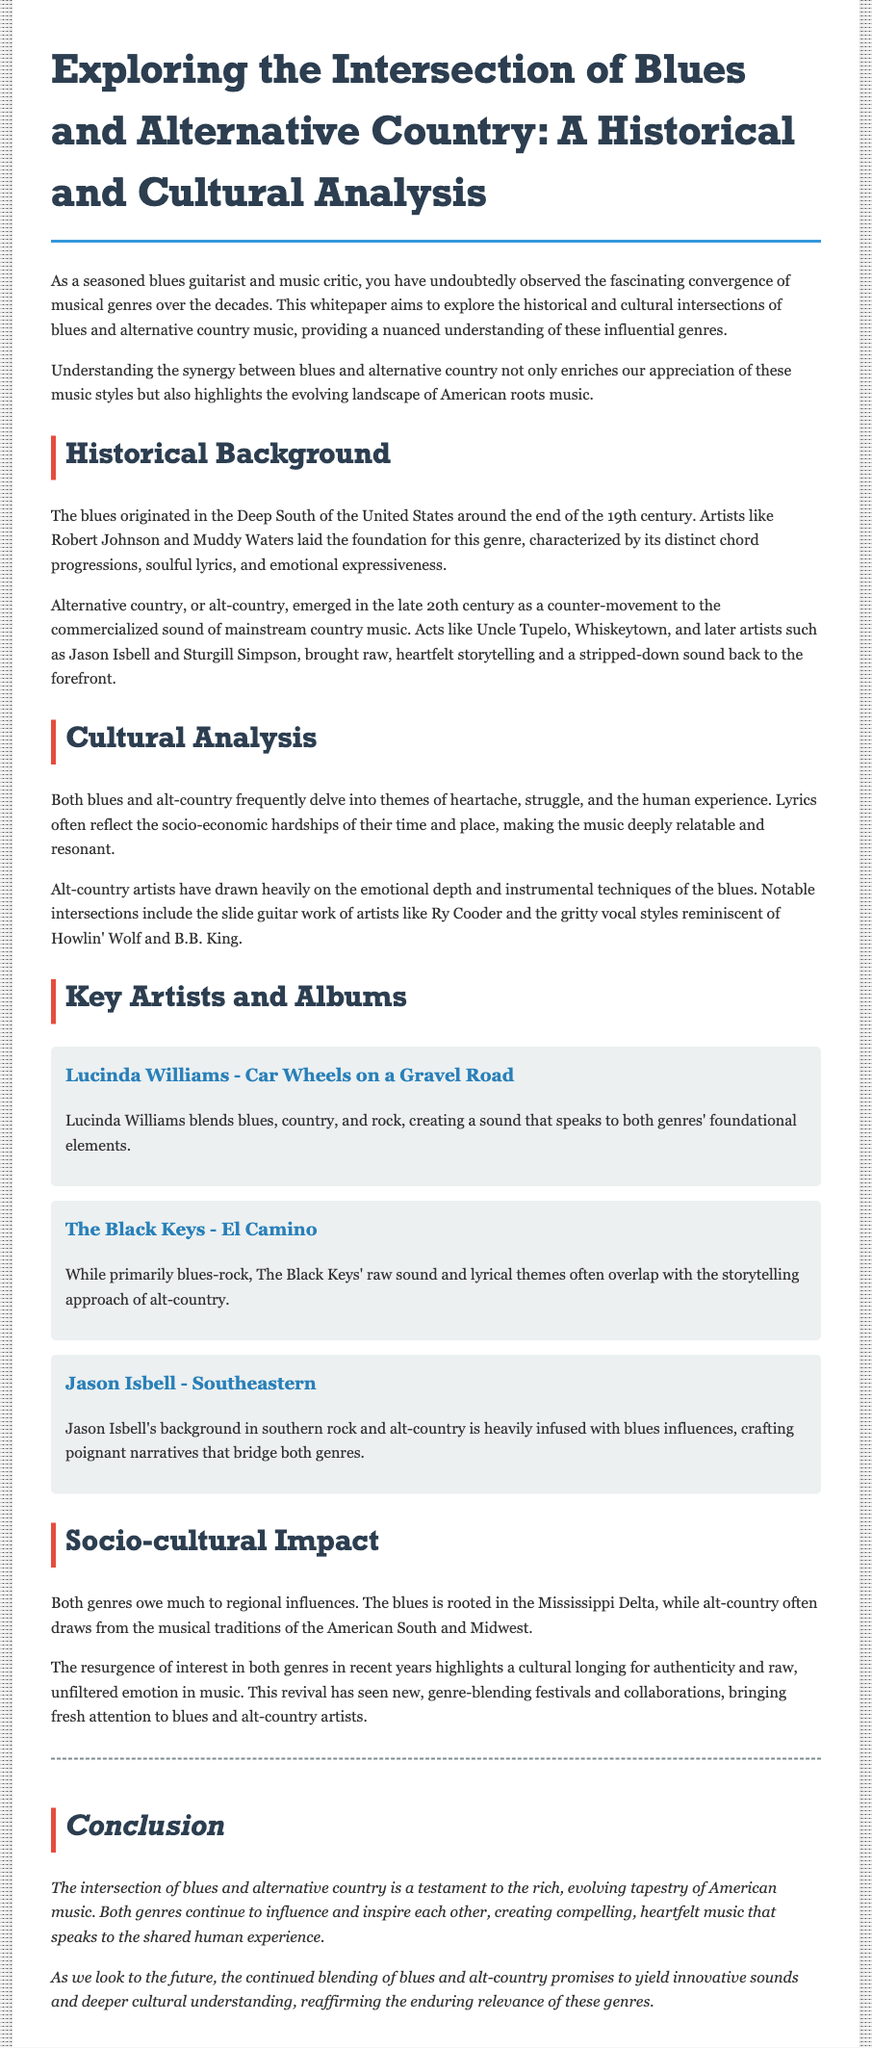What originated in the Deep South? The document states that the blues originated in the Deep South of the United States.
Answer: The blues Who are two early blues artists mentioned? The whitepaper names Robert Johnson and Muddy Waters as early blues artists.
Answer: Robert Johnson and Muddy Waters What is the title of Lucinda Williams' album discussed? The document refers to the album "Car Wheels on a Gravel Road" by Lucinda Williams.
Answer: Car Wheels on a Gravel Road Which recent artist is noted for blending blues with alt-country influences? The whitepaper mentions Jason Isbell as an artist whose music bridges both genres.
Answer: Jason Isbell What common themes do both genres explore? The document explains that blues and alt-country frequently delve into themes of heartache and struggle.
Answer: Heartache, struggle In what year did alternative country emerge? The whitepaper indicates that alternative country emerged in the late 20th century.
Answer: Late 20th century What musical element does Ry Cooder utilize that connects to blues? The document highlights slide guitar work as a notable connection between alt-country and blues.
Answer: Slide guitar What is the socio-cultural significance of blues and alt-country in recent years? The whitepaper notes a resurgence of interest in both genres, reflecting a longing for authenticity in music.
Answer: Resurgence of interest 